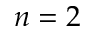<formula> <loc_0><loc_0><loc_500><loc_500>n = 2</formula> 